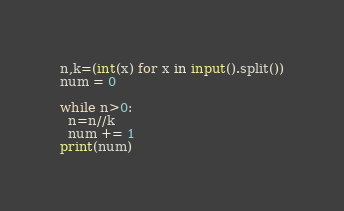<code> <loc_0><loc_0><loc_500><loc_500><_Python_>n,k=(int(x) for x in input().split())
num = 0

while n>0:
  n=n//k
  num += 1
print(num)</code> 